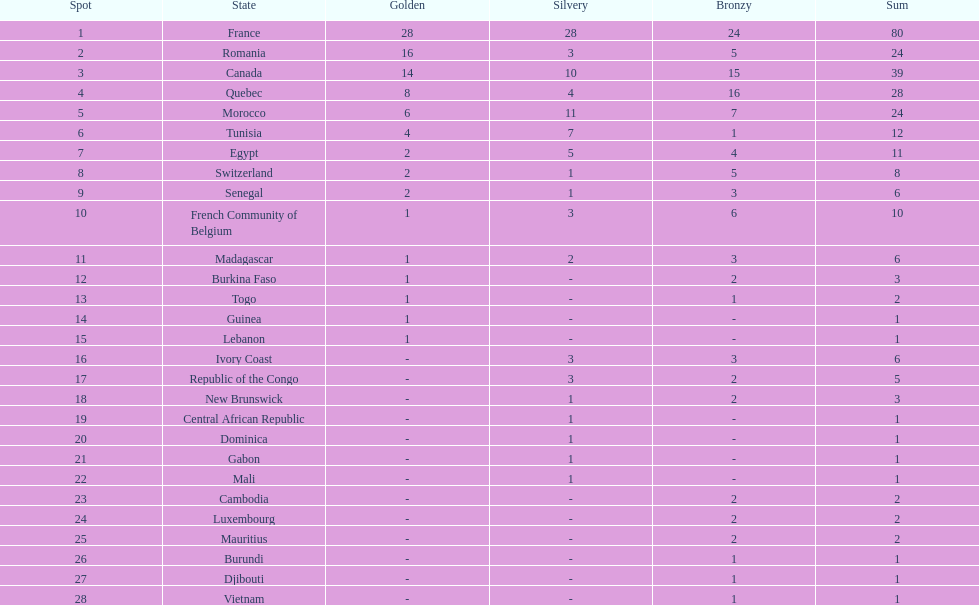Could you parse the entire table? {'header': ['Spot', 'State', 'Golden', 'Silvery', 'Bronzy', 'Sum'], 'rows': [['1', 'France', '28', '28', '24', '80'], ['2', 'Romania', '16', '3', '5', '24'], ['3', 'Canada', '14', '10', '15', '39'], ['4', 'Quebec', '8', '4', '16', '28'], ['5', 'Morocco', '6', '11', '7', '24'], ['6', 'Tunisia', '4', '7', '1', '12'], ['7', 'Egypt', '2', '5', '4', '11'], ['8', 'Switzerland', '2', '1', '5', '8'], ['9', 'Senegal', '2', '1', '3', '6'], ['10', 'French Community of Belgium', '1', '3', '6', '10'], ['11', 'Madagascar', '1', '2', '3', '6'], ['12', 'Burkina Faso', '1', '-', '2', '3'], ['13', 'Togo', '1', '-', '1', '2'], ['14', 'Guinea', '1', '-', '-', '1'], ['15', 'Lebanon', '1', '-', '-', '1'], ['16', 'Ivory Coast', '-', '3', '3', '6'], ['17', 'Republic of the Congo', '-', '3', '2', '5'], ['18', 'New Brunswick', '-', '1', '2', '3'], ['19', 'Central African Republic', '-', '1', '-', '1'], ['20', 'Dominica', '-', '1', '-', '1'], ['21', 'Gabon', '-', '1', '-', '1'], ['22', 'Mali', '-', '1', '-', '1'], ['23', 'Cambodia', '-', '-', '2', '2'], ['24', 'Luxembourg', '-', '-', '2', '2'], ['25', 'Mauritius', '-', '-', '2', '2'], ['26', 'Burundi', '-', '-', '1', '1'], ['27', 'Djibouti', '-', '-', '1', '1'], ['28', 'Vietnam', '-', '-', '1', '1']]} How many counties have at least one silver medal? 18. 